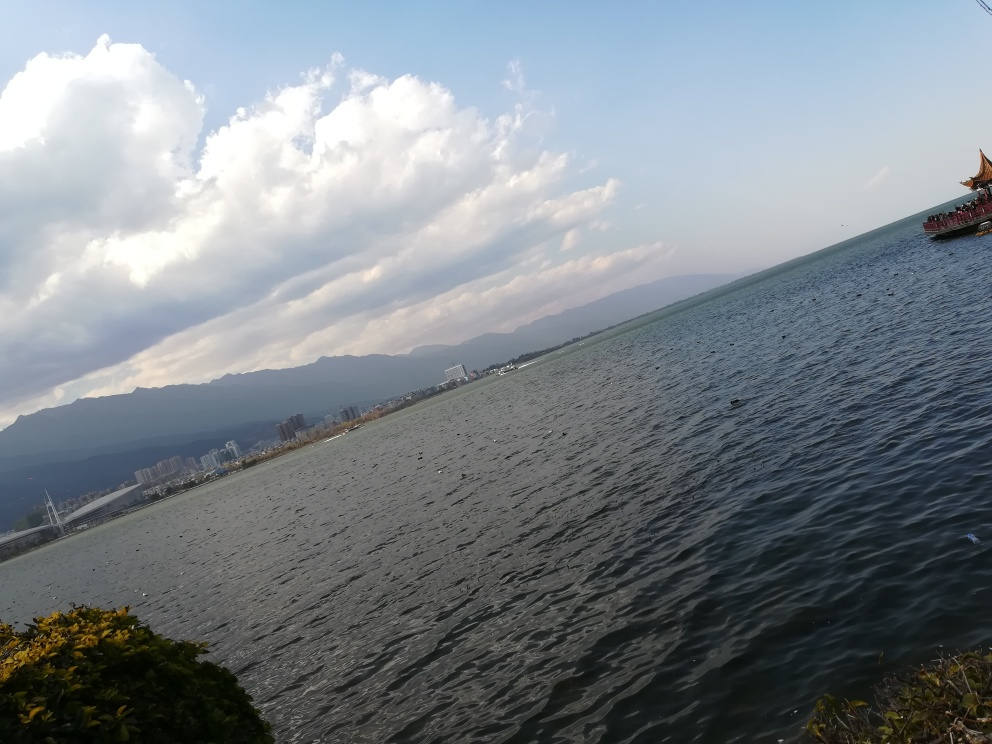What time of day does this photo appear to be taken? The photo appears to be taken in the late afternoon, judging by the long shadows and the warm tone of the light filtering through the clouds. 